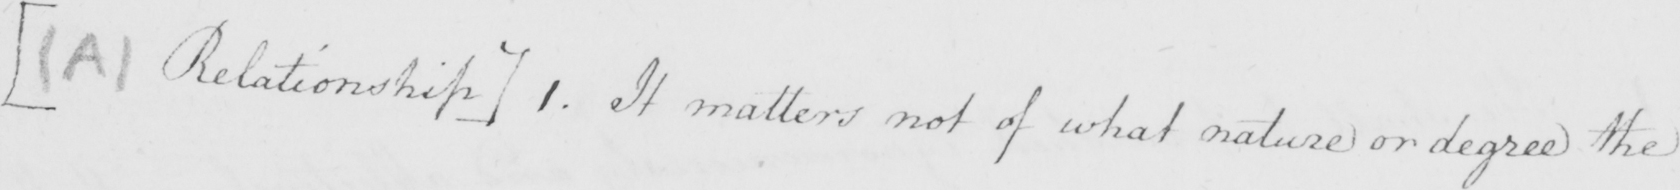What does this handwritten line say? [  ( A )  Relationship ] 1 . It matters not of what nature or degree the 